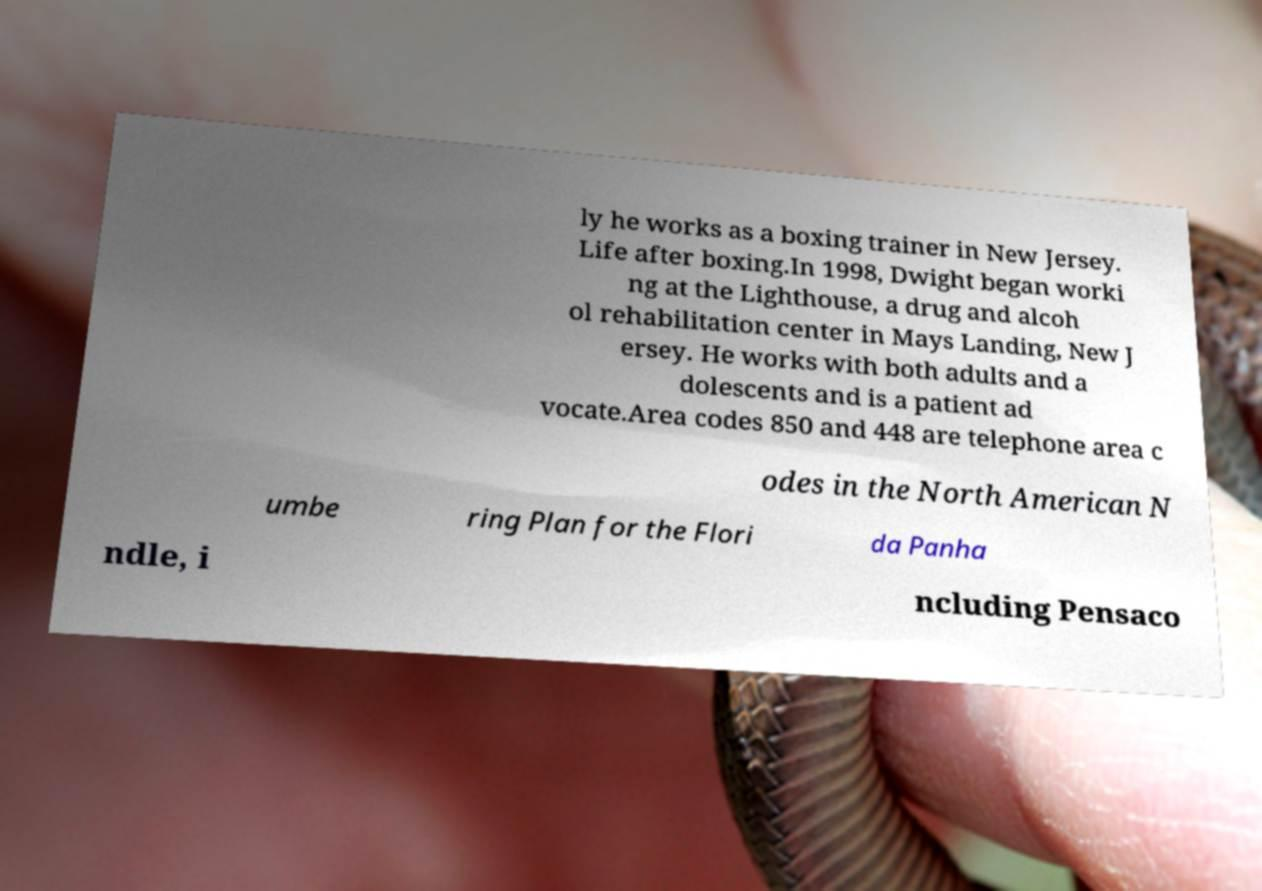Could you assist in decoding the text presented in this image and type it out clearly? ly he works as a boxing trainer in New Jersey. Life after boxing.In 1998, Dwight began worki ng at the Lighthouse, a drug and alcoh ol rehabilitation center in Mays Landing, New J ersey. He works with both adults and a dolescents and is a patient ad vocate.Area codes 850 and 448 are telephone area c odes in the North American N umbe ring Plan for the Flori da Panha ndle, i ncluding Pensaco 